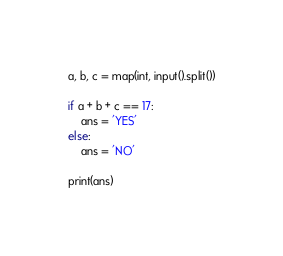Convert code to text. <code><loc_0><loc_0><loc_500><loc_500><_Python_>a, b, c = map(int, input().split())
 
if a + b + c == 17:
    ans = 'YES'
else:
    ans = 'NO'
 
print(ans)</code> 